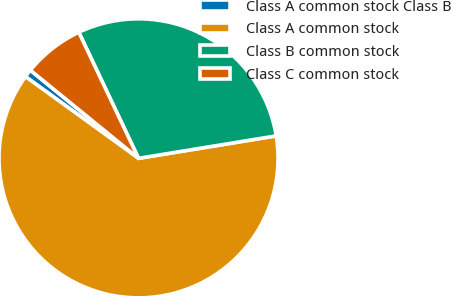<chart> <loc_0><loc_0><loc_500><loc_500><pie_chart><fcel>Class A common stock Class B<fcel>Class A common stock<fcel>Class B common stock<fcel>Class C common stock<nl><fcel>0.92%<fcel>62.54%<fcel>29.47%<fcel>7.08%<nl></chart> 